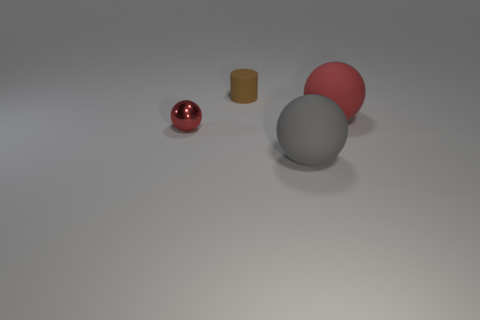Are there any other things that have the same material as the tiny red thing?
Offer a very short reply. No. There is a rubber thing that is right of the cylinder and behind the gray rubber sphere; how big is it?
Keep it short and to the point. Large. Are there fewer tiny things that are in front of the brown matte cylinder than large gray objects?
Make the answer very short. No. What shape is the red thing that is made of the same material as the brown cylinder?
Offer a terse response. Sphere. There is a red thing that is to the right of the small brown thing; is it the same shape as the red metallic object left of the large red ball?
Make the answer very short. Yes. Are there fewer small brown rubber things that are in front of the red rubber sphere than large matte balls that are in front of the tiny red shiny thing?
Your answer should be compact. Yes. There is a matte thing that is the same color as the small metallic ball; what is its shape?
Provide a short and direct response. Sphere. What number of matte objects have the same size as the red rubber ball?
Your answer should be compact. 1. Do the red thing to the right of the tiny metal ball and the tiny cylinder have the same material?
Provide a short and direct response. Yes. Is there a small cyan rubber object?
Your answer should be very brief. No. 